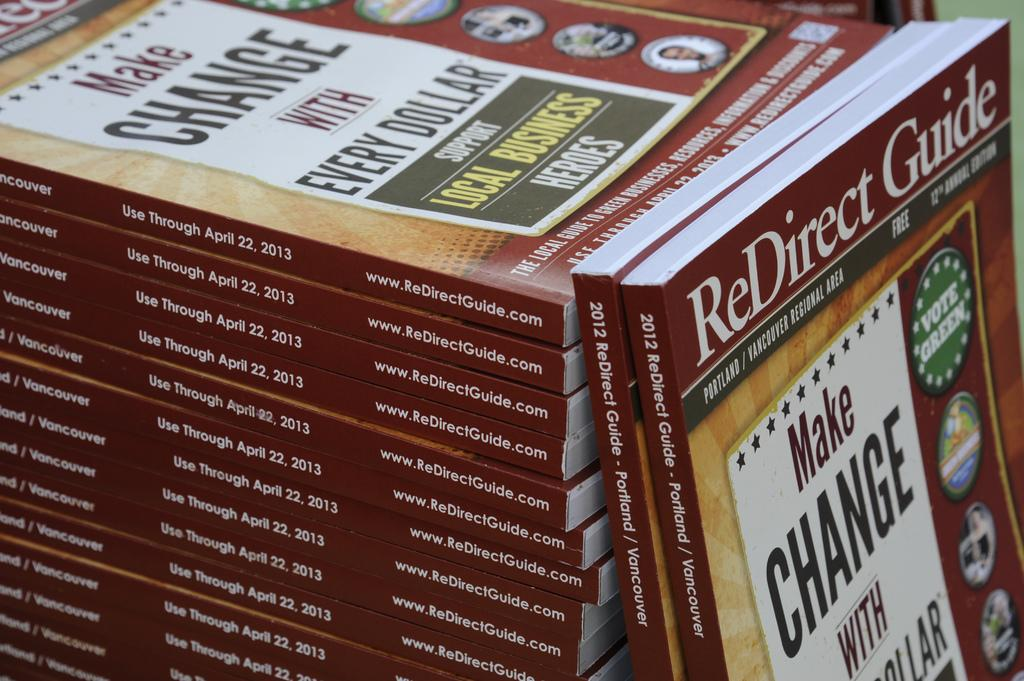<image>
Present a compact description of the photo's key features. Many red ReDirect guides are stacked on top of each other. 